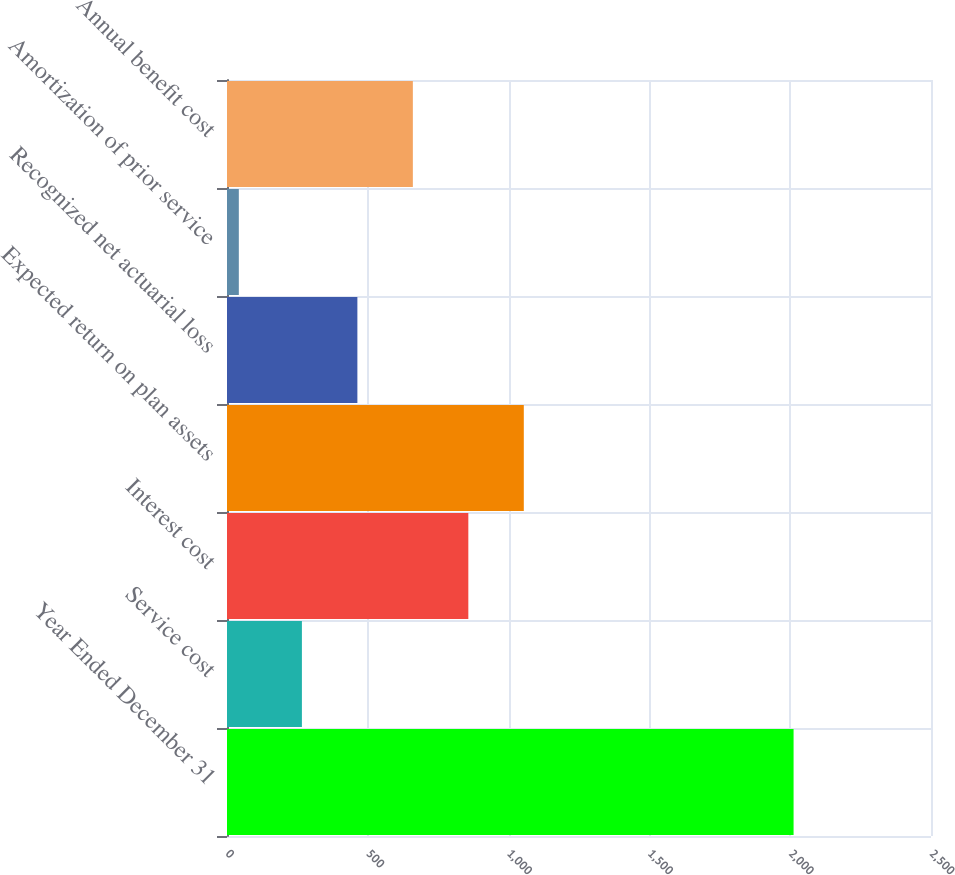Convert chart. <chart><loc_0><loc_0><loc_500><loc_500><bar_chart><fcel>Year Ended December 31<fcel>Service cost<fcel>Interest cost<fcel>Expected return on plan assets<fcel>Recognized net actuarial loss<fcel>Amortization of prior service<fcel>Annual benefit cost<nl><fcel>2012<fcel>266<fcel>857<fcel>1054<fcel>463<fcel>42<fcel>660<nl></chart> 